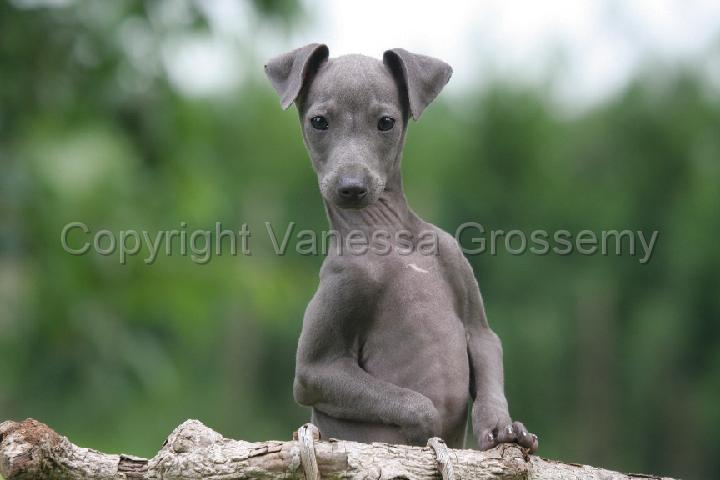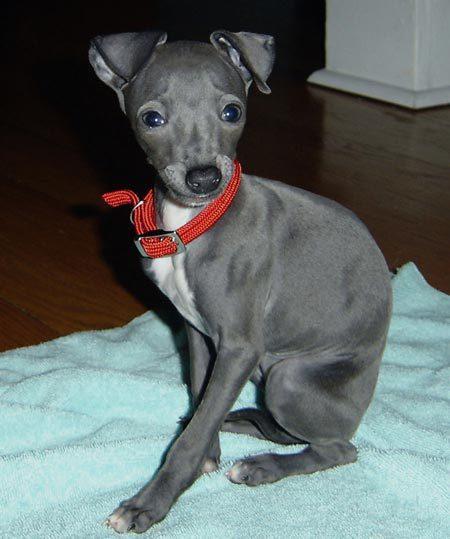The first image is the image on the left, the second image is the image on the right. For the images displayed, is the sentence "There is one dog with a red collar around its neck." factually correct? Answer yes or no. Yes. The first image is the image on the left, the second image is the image on the right. Considering the images on both sides, is "In both images the dogs are on the grass." valid? Answer yes or no. No. 